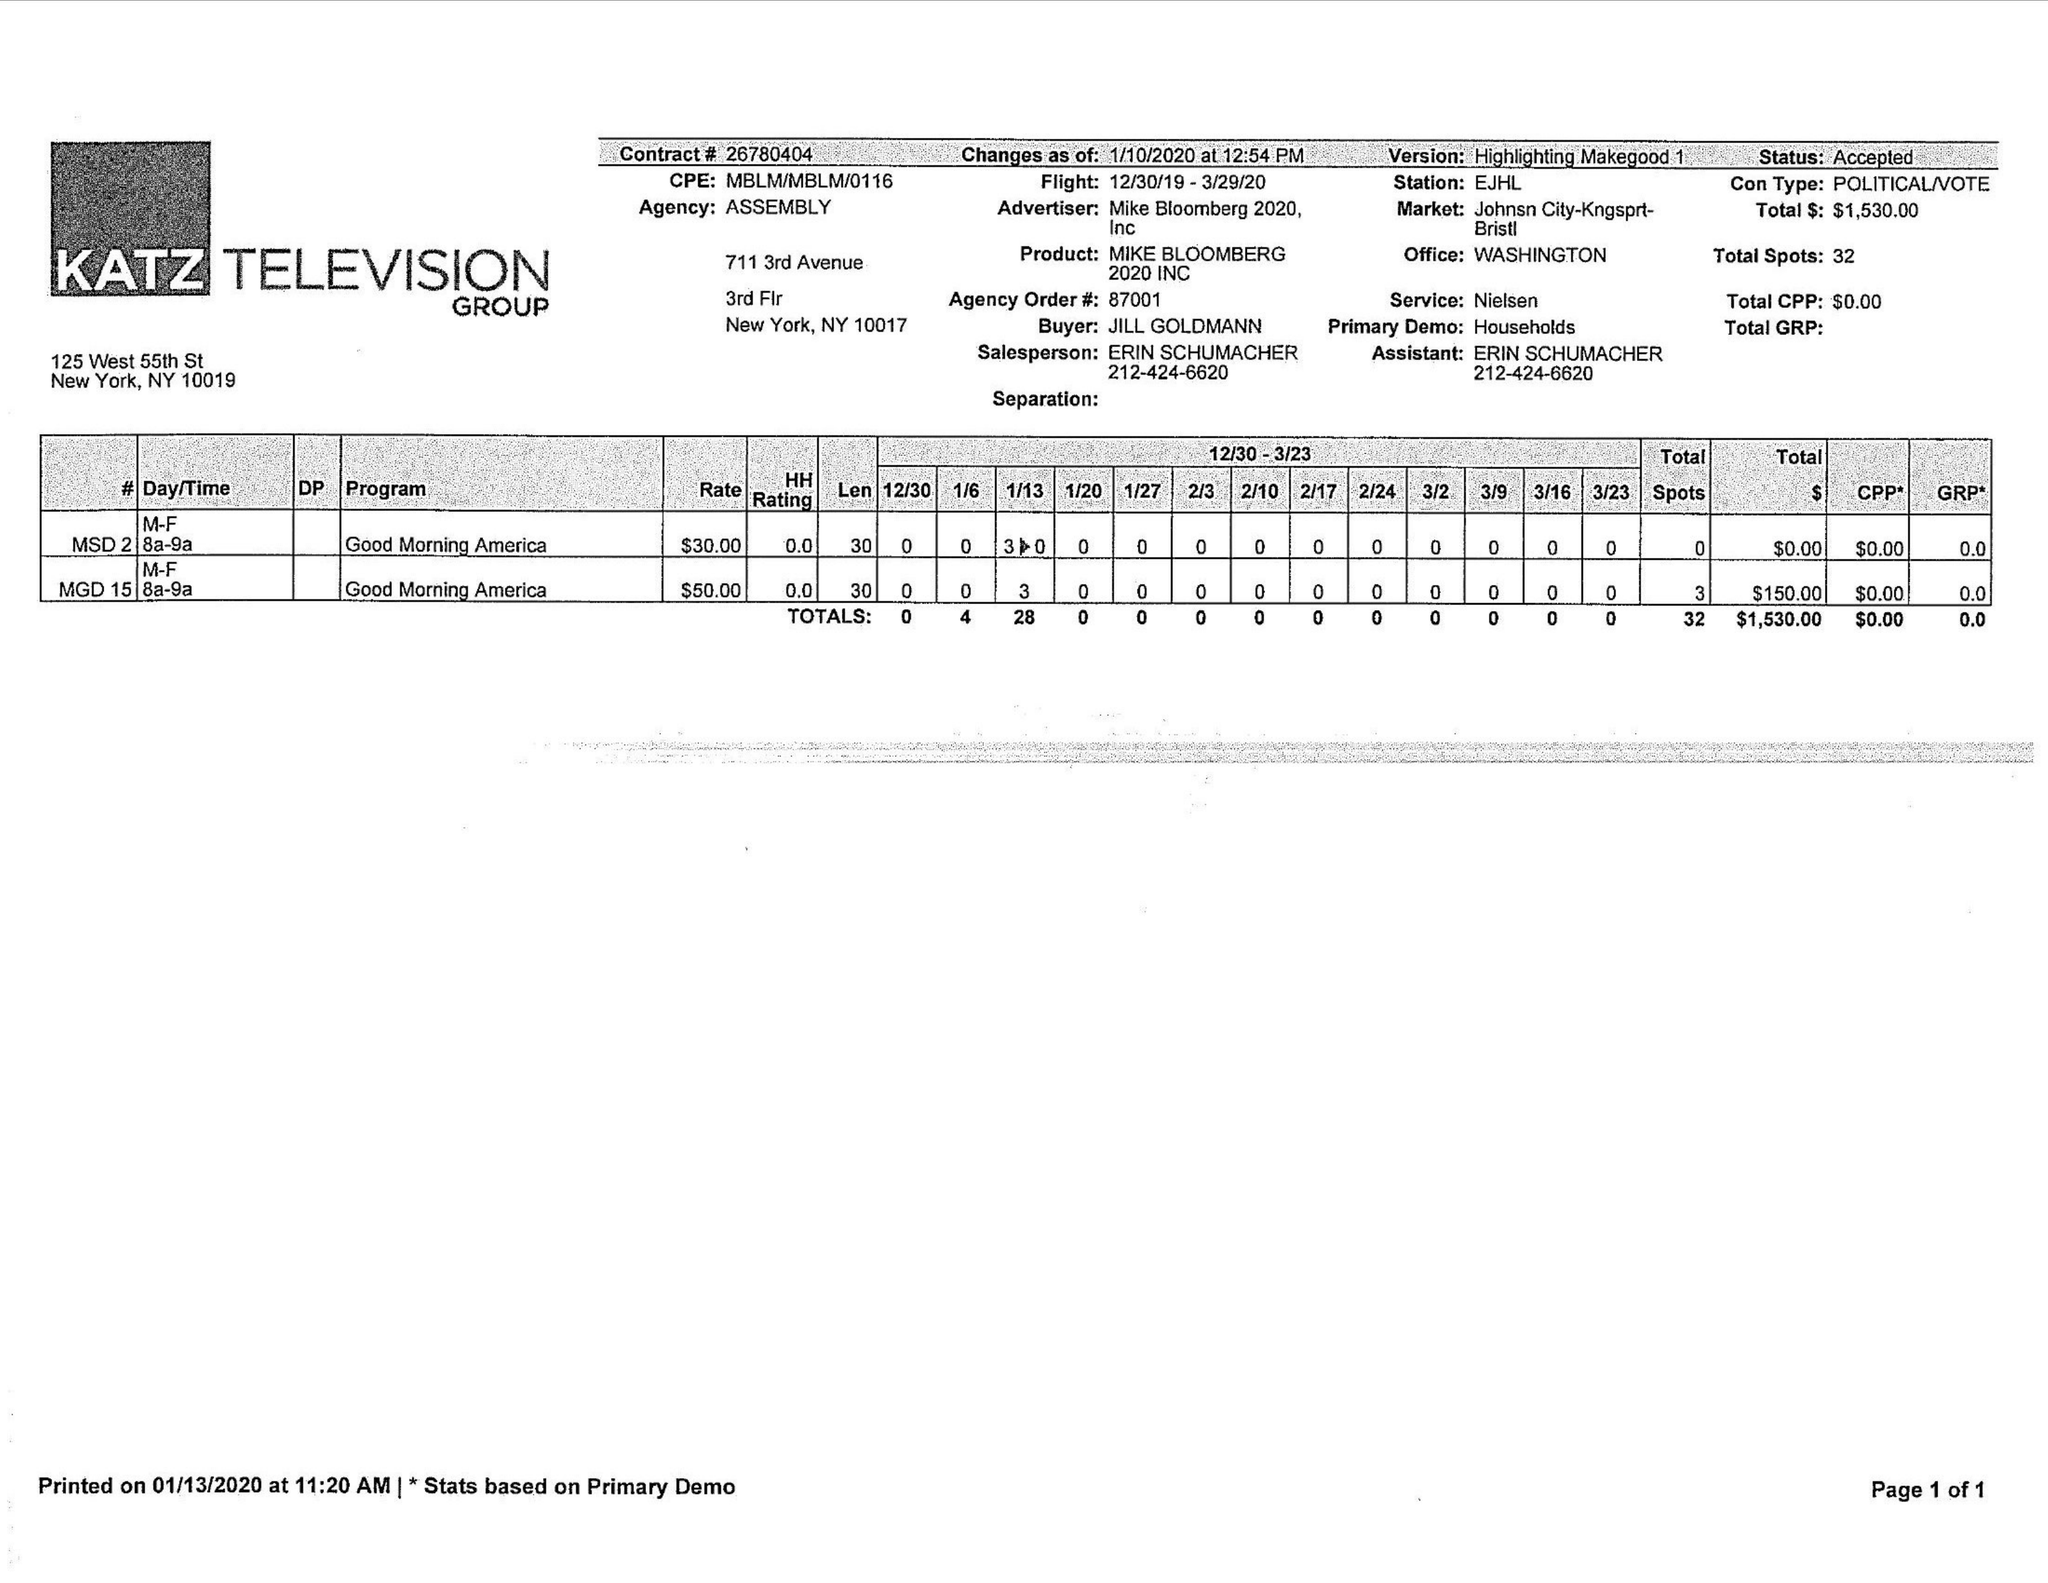What is the value for the contract_num?
Answer the question using a single word or phrase. 26780404 